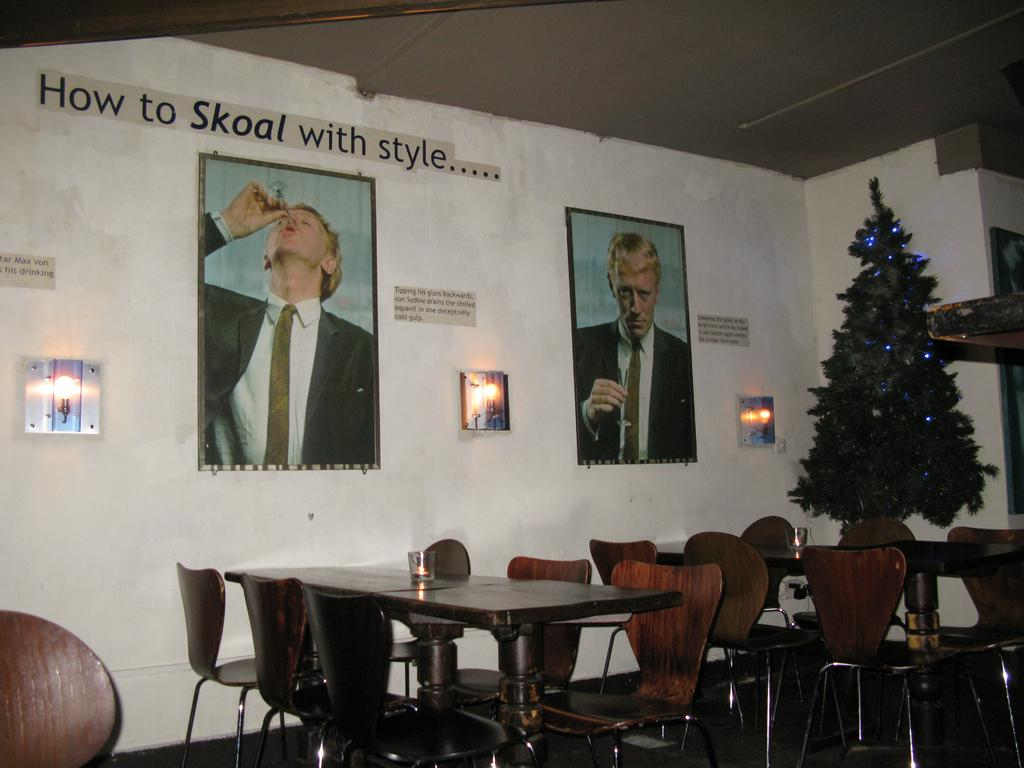What type of furniture is present in the image? There are dining tables in the image. What natural element can be seen in the image? There is a tree visible in the image. What decorative items are on the wall in the image? There are posters on the wall in the image. What color is the toe of the person sitting at the table in the image? There is no person or toe visible in the image; it only shows dining tables, a tree, and posters on the wall. 